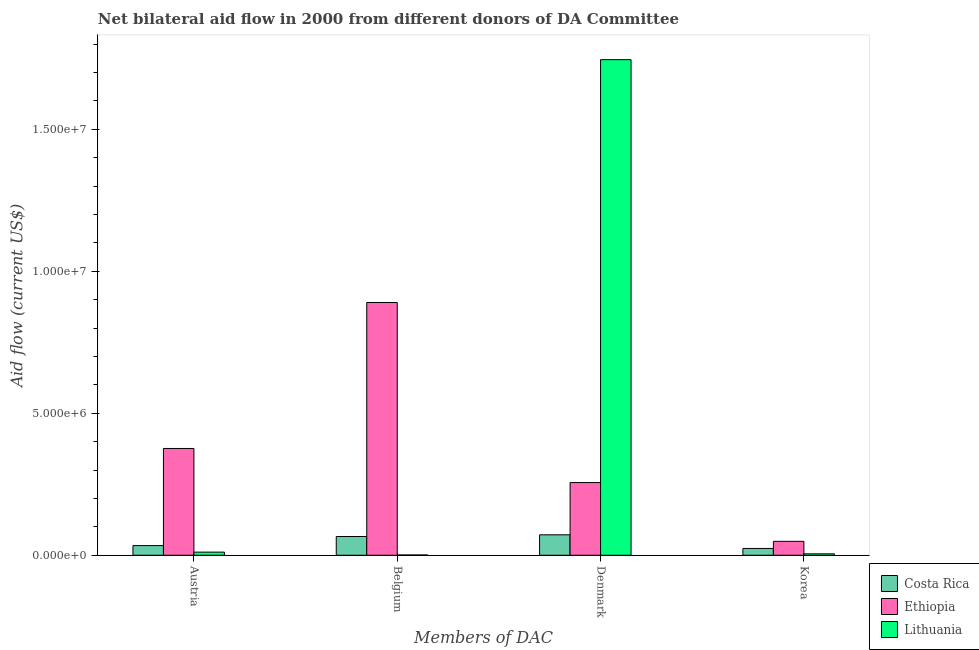How many different coloured bars are there?
Your answer should be very brief. 3. Are the number of bars per tick equal to the number of legend labels?
Your response must be concise. Yes. Are the number of bars on each tick of the X-axis equal?
Your response must be concise. Yes. What is the amount of aid given by korea in Lithuania?
Your response must be concise. 5.00e+04. Across all countries, what is the maximum amount of aid given by belgium?
Your answer should be compact. 8.90e+06. Across all countries, what is the minimum amount of aid given by belgium?
Your answer should be very brief. 10000. In which country was the amount of aid given by austria maximum?
Give a very brief answer. Ethiopia. In which country was the amount of aid given by korea minimum?
Ensure brevity in your answer.  Lithuania. What is the total amount of aid given by belgium in the graph?
Your response must be concise. 9.57e+06. What is the difference between the amount of aid given by korea in Costa Rica and that in Ethiopia?
Offer a very short reply. -2.50e+05. What is the difference between the amount of aid given by belgium in Ethiopia and the amount of aid given by denmark in Lithuania?
Provide a succinct answer. -8.55e+06. What is the average amount of aid given by denmark per country?
Provide a succinct answer. 6.91e+06. What is the difference between the amount of aid given by austria and amount of aid given by denmark in Costa Rica?
Ensure brevity in your answer.  -3.80e+05. In how many countries, is the amount of aid given by denmark greater than 8000000 US$?
Provide a succinct answer. 1. What is the ratio of the amount of aid given by denmark in Lithuania to that in Costa Rica?
Offer a terse response. 24.24. What is the difference between the highest and the second highest amount of aid given by belgium?
Provide a short and direct response. 8.24e+06. What is the difference between the highest and the lowest amount of aid given by austria?
Provide a short and direct response. 3.65e+06. In how many countries, is the amount of aid given by austria greater than the average amount of aid given by austria taken over all countries?
Provide a short and direct response. 1. Is it the case that in every country, the sum of the amount of aid given by korea and amount of aid given by belgium is greater than the sum of amount of aid given by austria and amount of aid given by denmark?
Ensure brevity in your answer.  No. What does the 3rd bar from the left in Belgium represents?
Give a very brief answer. Lithuania. What does the 3rd bar from the right in Austria represents?
Your answer should be compact. Costa Rica. How many countries are there in the graph?
Ensure brevity in your answer.  3. What is the difference between two consecutive major ticks on the Y-axis?
Give a very brief answer. 5.00e+06. Does the graph contain any zero values?
Make the answer very short. No. Where does the legend appear in the graph?
Provide a short and direct response. Bottom right. How many legend labels are there?
Make the answer very short. 3. What is the title of the graph?
Keep it short and to the point. Net bilateral aid flow in 2000 from different donors of DA Committee. Does "St. Lucia" appear as one of the legend labels in the graph?
Provide a short and direct response. No. What is the label or title of the X-axis?
Keep it short and to the point. Members of DAC. What is the label or title of the Y-axis?
Provide a short and direct response. Aid flow (current US$). What is the Aid flow (current US$) in Costa Rica in Austria?
Your answer should be compact. 3.40e+05. What is the Aid flow (current US$) in Ethiopia in Austria?
Your response must be concise. 3.76e+06. What is the Aid flow (current US$) in Costa Rica in Belgium?
Keep it short and to the point. 6.60e+05. What is the Aid flow (current US$) of Ethiopia in Belgium?
Provide a short and direct response. 8.90e+06. What is the Aid flow (current US$) in Lithuania in Belgium?
Keep it short and to the point. 10000. What is the Aid flow (current US$) of Costa Rica in Denmark?
Give a very brief answer. 7.20e+05. What is the Aid flow (current US$) of Ethiopia in Denmark?
Your answer should be compact. 2.56e+06. What is the Aid flow (current US$) in Lithuania in Denmark?
Provide a succinct answer. 1.74e+07. Across all Members of DAC, what is the maximum Aid flow (current US$) in Costa Rica?
Provide a succinct answer. 7.20e+05. Across all Members of DAC, what is the maximum Aid flow (current US$) of Ethiopia?
Ensure brevity in your answer.  8.90e+06. Across all Members of DAC, what is the maximum Aid flow (current US$) of Lithuania?
Ensure brevity in your answer.  1.74e+07. Across all Members of DAC, what is the minimum Aid flow (current US$) of Lithuania?
Your answer should be very brief. 10000. What is the total Aid flow (current US$) in Costa Rica in the graph?
Your answer should be very brief. 1.96e+06. What is the total Aid flow (current US$) in Ethiopia in the graph?
Your response must be concise. 1.57e+07. What is the total Aid flow (current US$) in Lithuania in the graph?
Ensure brevity in your answer.  1.76e+07. What is the difference between the Aid flow (current US$) in Costa Rica in Austria and that in Belgium?
Your answer should be very brief. -3.20e+05. What is the difference between the Aid flow (current US$) in Ethiopia in Austria and that in Belgium?
Your response must be concise. -5.14e+06. What is the difference between the Aid flow (current US$) of Costa Rica in Austria and that in Denmark?
Offer a very short reply. -3.80e+05. What is the difference between the Aid flow (current US$) of Ethiopia in Austria and that in Denmark?
Your response must be concise. 1.20e+06. What is the difference between the Aid flow (current US$) in Lithuania in Austria and that in Denmark?
Your answer should be compact. -1.73e+07. What is the difference between the Aid flow (current US$) in Costa Rica in Austria and that in Korea?
Provide a succinct answer. 1.00e+05. What is the difference between the Aid flow (current US$) in Ethiopia in Austria and that in Korea?
Keep it short and to the point. 3.27e+06. What is the difference between the Aid flow (current US$) of Costa Rica in Belgium and that in Denmark?
Offer a terse response. -6.00e+04. What is the difference between the Aid flow (current US$) of Ethiopia in Belgium and that in Denmark?
Provide a short and direct response. 6.34e+06. What is the difference between the Aid flow (current US$) of Lithuania in Belgium and that in Denmark?
Make the answer very short. -1.74e+07. What is the difference between the Aid flow (current US$) of Ethiopia in Belgium and that in Korea?
Provide a short and direct response. 8.41e+06. What is the difference between the Aid flow (current US$) in Lithuania in Belgium and that in Korea?
Make the answer very short. -4.00e+04. What is the difference between the Aid flow (current US$) in Ethiopia in Denmark and that in Korea?
Make the answer very short. 2.07e+06. What is the difference between the Aid flow (current US$) in Lithuania in Denmark and that in Korea?
Keep it short and to the point. 1.74e+07. What is the difference between the Aid flow (current US$) of Costa Rica in Austria and the Aid flow (current US$) of Ethiopia in Belgium?
Keep it short and to the point. -8.56e+06. What is the difference between the Aid flow (current US$) of Ethiopia in Austria and the Aid flow (current US$) of Lithuania in Belgium?
Provide a short and direct response. 3.75e+06. What is the difference between the Aid flow (current US$) in Costa Rica in Austria and the Aid flow (current US$) in Ethiopia in Denmark?
Your response must be concise. -2.22e+06. What is the difference between the Aid flow (current US$) in Costa Rica in Austria and the Aid flow (current US$) in Lithuania in Denmark?
Keep it short and to the point. -1.71e+07. What is the difference between the Aid flow (current US$) in Ethiopia in Austria and the Aid flow (current US$) in Lithuania in Denmark?
Your answer should be compact. -1.37e+07. What is the difference between the Aid flow (current US$) in Ethiopia in Austria and the Aid flow (current US$) in Lithuania in Korea?
Provide a short and direct response. 3.71e+06. What is the difference between the Aid flow (current US$) in Costa Rica in Belgium and the Aid flow (current US$) in Ethiopia in Denmark?
Provide a succinct answer. -1.90e+06. What is the difference between the Aid flow (current US$) in Costa Rica in Belgium and the Aid flow (current US$) in Lithuania in Denmark?
Offer a very short reply. -1.68e+07. What is the difference between the Aid flow (current US$) in Ethiopia in Belgium and the Aid flow (current US$) in Lithuania in Denmark?
Keep it short and to the point. -8.55e+06. What is the difference between the Aid flow (current US$) of Costa Rica in Belgium and the Aid flow (current US$) of Ethiopia in Korea?
Make the answer very short. 1.70e+05. What is the difference between the Aid flow (current US$) in Ethiopia in Belgium and the Aid flow (current US$) in Lithuania in Korea?
Your answer should be very brief. 8.85e+06. What is the difference between the Aid flow (current US$) in Costa Rica in Denmark and the Aid flow (current US$) in Lithuania in Korea?
Give a very brief answer. 6.70e+05. What is the difference between the Aid flow (current US$) in Ethiopia in Denmark and the Aid flow (current US$) in Lithuania in Korea?
Offer a very short reply. 2.51e+06. What is the average Aid flow (current US$) of Ethiopia per Members of DAC?
Provide a short and direct response. 3.93e+06. What is the average Aid flow (current US$) of Lithuania per Members of DAC?
Your answer should be compact. 4.40e+06. What is the difference between the Aid flow (current US$) of Costa Rica and Aid flow (current US$) of Ethiopia in Austria?
Ensure brevity in your answer.  -3.42e+06. What is the difference between the Aid flow (current US$) of Costa Rica and Aid flow (current US$) of Lithuania in Austria?
Give a very brief answer. 2.30e+05. What is the difference between the Aid flow (current US$) of Ethiopia and Aid flow (current US$) of Lithuania in Austria?
Your answer should be very brief. 3.65e+06. What is the difference between the Aid flow (current US$) of Costa Rica and Aid flow (current US$) of Ethiopia in Belgium?
Your response must be concise. -8.24e+06. What is the difference between the Aid flow (current US$) of Costa Rica and Aid flow (current US$) of Lithuania in Belgium?
Ensure brevity in your answer.  6.50e+05. What is the difference between the Aid flow (current US$) of Ethiopia and Aid flow (current US$) of Lithuania in Belgium?
Offer a very short reply. 8.89e+06. What is the difference between the Aid flow (current US$) of Costa Rica and Aid flow (current US$) of Ethiopia in Denmark?
Make the answer very short. -1.84e+06. What is the difference between the Aid flow (current US$) in Costa Rica and Aid flow (current US$) in Lithuania in Denmark?
Your response must be concise. -1.67e+07. What is the difference between the Aid flow (current US$) of Ethiopia and Aid flow (current US$) of Lithuania in Denmark?
Your response must be concise. -1.49e+07. What is the difference between the Aid flow (current US$) of Ethiopia and Aid flow (current US$) of Lithuania in Korea?
Your answer should be very brief. 4.40e+05. What is the ratio of the Aid flow (current US$) in Costa Rica in Austria to that in Belgium?
Keep it short and to the point. 0.52. What is the ratio of the Aid flow (current US$) in Ethiopia in Austria to that in Belgium?
Your answer should be compact. 0.42. What is the ratio of the Aid flow (current US$) of Costa Rica in Austria to that in Denmark?
Keep it short and to the point. 0.47. What is the ratio of the Aid flow (current US$) of Ethiopia in Austria to that in Denmark?
Your answer should be compact. 1.47. What is the ratio of the Aid flow (current US$) of Lithuania in Austria to that in Denmark?
Provide a succinct answer. 0.01. What is the ratio of the Aid flow (current US$) in Costa Rica in Austria to that in Korea?
Your answer should be very brief. 1.42. What is the ratio of the Aid flow (current US$) of Ethiopia in Austria to that in Korea?
Keep it short and to the point. 7.67. What is the ratio of the Aid flow (current US$) in Ethiopia in Belgium to that in Denmark?
Make the answer very short. 3.48. What is the ratio of the Aid flow (current US$) in Lithuania in Belgium to that in Denmark?
Ensure brevity in your answer.  0. What is the ratio of the Aid flow (current US$) in Costa Rica in Belgium to that in Korea?
Provide a succinct answer. 2.75. What is the ratio of the Aid flow (current US$) in Ethiopia in Belgium to that in Korea?
Give a very brief answer. 18.16. What is the ratio of the Aid flow (current US$) of Lithuania in Belgium to that in Korea?
Offer a terse response. 0.2. What is the ratio of the Aid flow (current US$) in Ethiopia in Denmark to that in Korea?
Provide a short and direct response. 5.22. What is the ratio of the Aid flow (current US$) of Lithuania in Denmark to that in Korea?
Your answer should be compact. 349. What is the difference between the highest and the second highest Aid flow (current US$) of Ethiopia?
Offer a very short reply. 5.14e+06. What is the difference between the highest and the second highest Aid flow (current US$) of Lithuania?
Provide a short and direct response. 1.73e+07. What is the difference between the highest and the lowest Aid flow (current US$) of Ethiopia?
Your answer should be compact. 8.41e+06. What is the difference between the highest and the lowest Aid flow (current US$) of Lithuania?
Provide a short and direct response. 1.74e+07. 